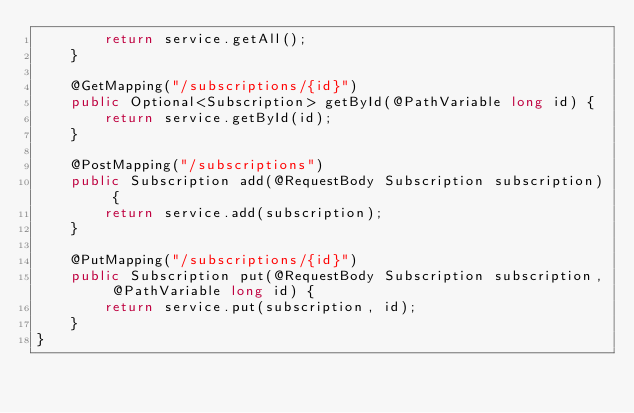<code> <loc_0><loc_0><loc_500><loc_500><_Java_>        return service.getAll();
    }

    @GetMapping("/subscriptions/{id}")
    public Optional<Subscription> getById(@PathVariable long id) {
        return service.getById(id);
    }

    @PostMapping("/subscriptions")
    public Subscription add(@RequestBody Subscription subscription) {
        return service.add(subscription);
    }

    @PutMapping("/subscriptions/{id}")
    public Subscription put(@RequestBody Subscription subscription, @PathVariable long id) {
        return service.put(subscription, id);
    }
}</code> 